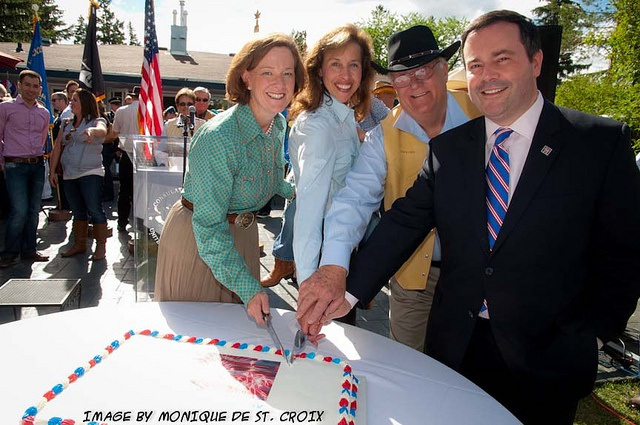Describe the objects in this image and their specific colors. I can see people in black, brown, gray, and darkgray tones, dining table in black, white, darkgray, and gray tones, cake in black, white, darkgray, lightpink, and lightgray tones, people in black, gray, and teal tones, and people in black, brown, gray, and darkgray tones in this image. 